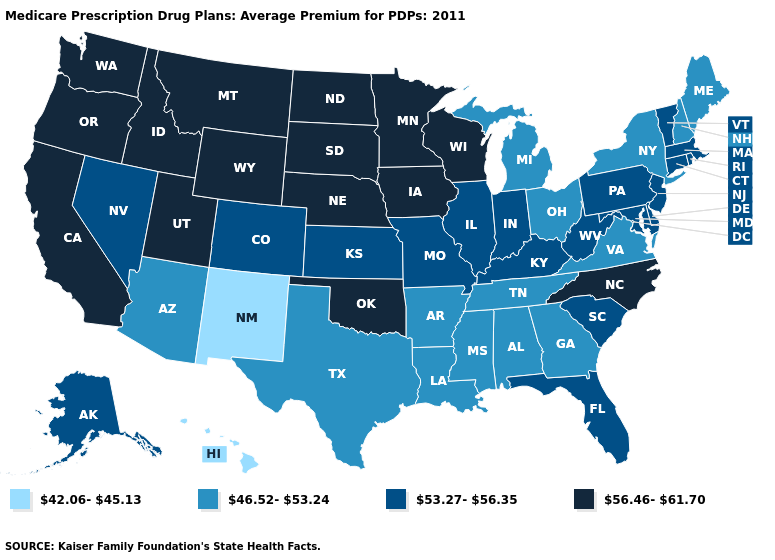Is the legend a continuous bar?
Answer briefly. No. What is the value of Connecticut?
Be succinct. 53.27-56.35. What is the highest value in states that border New Hampshire?
Keep it brief. 53.27-56.35. What is the value of Kentucky?
Keep it brief. 53.27-56.35. What is the value of Oklahoma?
Concise answer only. 56.46-61.70. Does Maine have a lower value than Louisiana?
Concise answer only. No. Name the states that have a value in the range 46.52-53.24?
Be succinct. Alabama, Arkansas, Arizona, Georgia, Louisiana, Maine, Michigan, Mississippi, New Hampshire, New York, Ohio, Tennessee, Texas, Virginia. What is the value of North Dakota?
Write a very short answer. 56.46-61.70. What is the value of North Carolina?
Concise answer only. 56.46-61.70. Does the first symbol in the legend represent the smallest category?
Quick response, please. Yes. Name the states that have a value in the range 42.06-45.13?
Give a very brief answer. Hawaii, New Mexico. Which states hav the highest value in the West?
Concise answer only. California, Idaho, Montana, Oregon, Utah, Washington, Wyoming. Which states have the lowest value in the USA?
Be succinct. Hawaii, New Mexico. Does Maine have the highest value in the USA?
Be succinct. No. Name the states that have a value in the range 56.46-61.70?
Answer briefly. California, Iowa, Idaho, Minnesota, Montana, North Carolina, North Dakota, Nebraska, Oklahoma, Oregon, South Dakota, Utah, Washington, Wisconsin, Wyoming. 